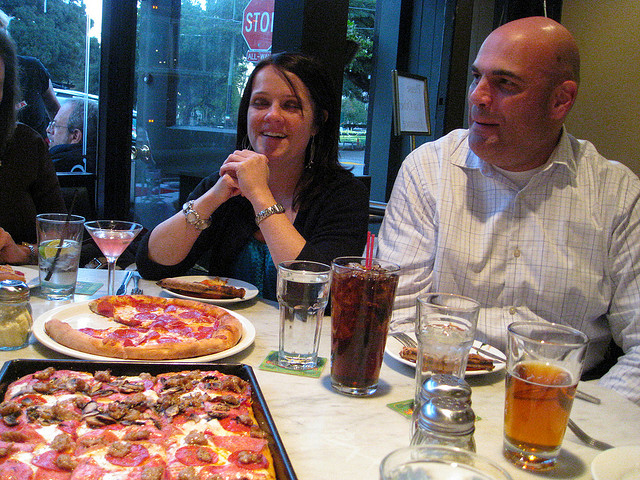How would you describe the body language of the people? The individuals present are engaged and comfortable, with the woman smiling and resting her chin on her hands, indicating a relaxed and happy mood. The man appears to be in a neutral, attentive state, perhaps listening to someone speaking or waiting for his turn to engage in the conversation.  What can you infer about their relationship? While the specific nature of their relationship isn't clear, their body language and proximity suggest they are well-acquainted with each other. They seem to be sharing a casual dining experience, possibly as friends, colleagues, or family members comfortably enjoying each other's company. 